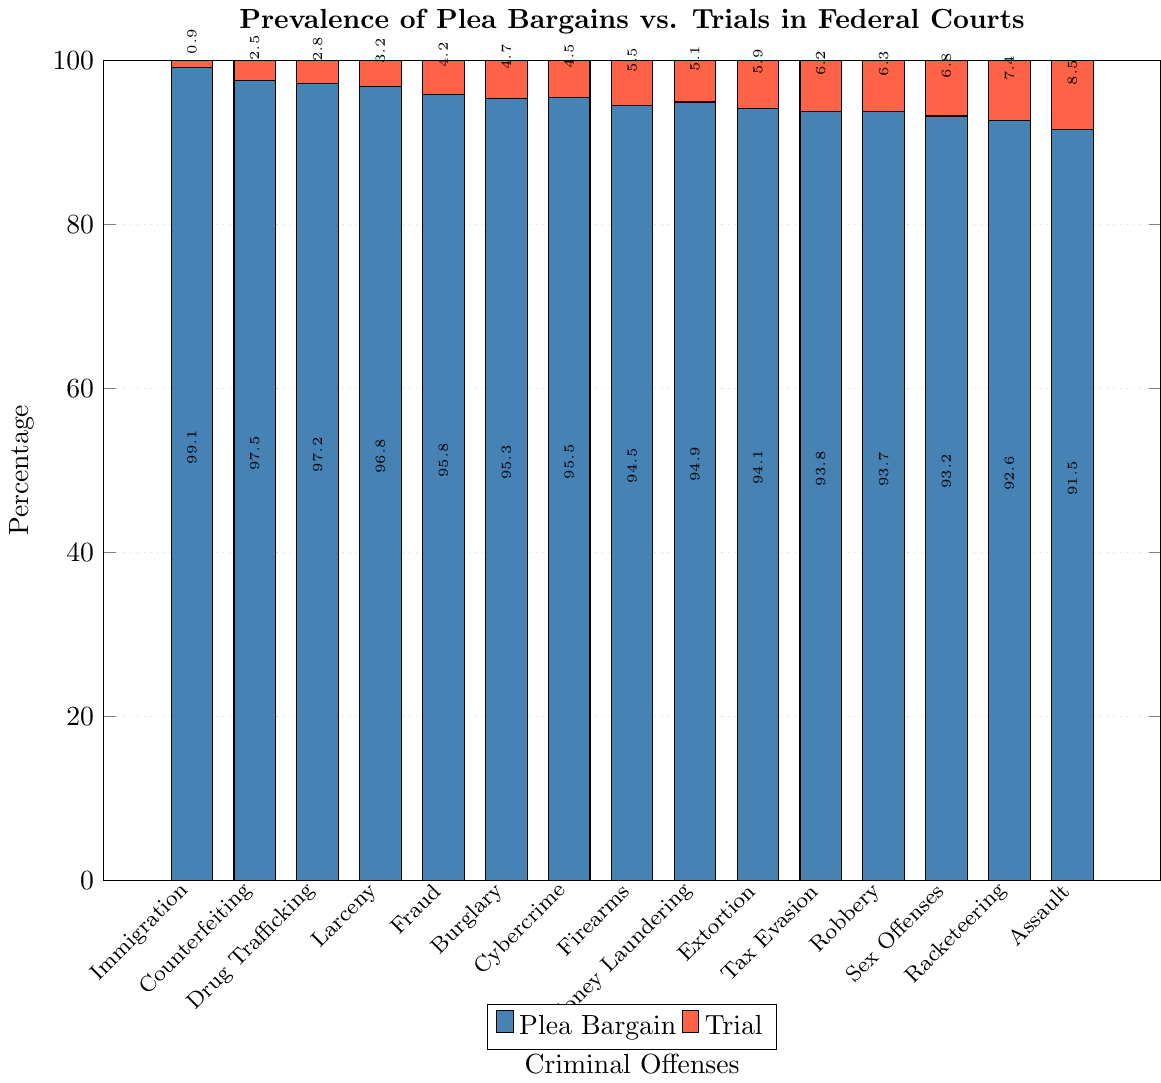What is the most common outcome for Drug Trafficking cases? Drug Trafficking cases have a plea bargain rate of 97.2% and a trial rate of 2.8%. The higher percentage indicates that plea bargains are the most common outcome for Drug Trafficking cases.
Answer: Plea Bargain Which offense has the highest percentage of plea bargains? The offense with the highest percentage of plea bargains is Immigration with 99.1%. This can be determined by looking at the bar heights for plea bargains across all offenses and identifying the tallest bar.
Answer: Immigration What is the difference in trial percentages between Assault and Fraud? The trial percentage for Assault is 8.5%, and for Fraud, it is 4.2%. The difference is calculated as 8.5% - 4.2% = 4.3%.
Answer: 4.3% Which two offenses have the smallest gap between plea bargains and trials? To find the smallest gap, we look at the differences between plea bargain and trial percentages for each offense. The offenses with the smallest gaps are likely to be close in their bar heights. Money Laundering has a plea bargain rate of 94.9% and a trial rate of 5.1%, giving a gap of 94.9% - 5.1% = 89.8%.
Answer: Money Laundering How many offenses have a trial percentage higher than 5%? By examining the graph, we count the bars representing trials that exceed 5% in height. The offenses with trial percentages higher than 5% are Assault (8.5%), Racketeering (7.4%), Sex Offenses (6.8%), Robbery (6.3%), Tax Evasion (6.2%), Firearms (5.5%), Money Laundering (5.1%), and Extortion (5.9%), yielding a total of 8 offenses.
Answer: 8 offenses What is the average trial percentage across all offenses? To calculate the average trial percentage, we sum the trial percentages for all offenses and divide by the number of offenses. The sum is 2.8% (Drug Trafficking) + 4.2% (Fraud) + 5.5% (Firearms) + 0.9% (Immigration) + 6.3% (Robbery) + 6.8% (Sex Offenses) + 8.5% (Assault) + 4.7% (Burglary) + 3.2% (Larceny) + 5.1% (Money Laundering) + 7.4% (Racketeering) + 4.5% (Cybercrime) + 6.2% (Tax Evasion) + 2.5% (Counterfeiting) + 5.9% (Extortion) = 74.5%. Then, 74.5% / 15 = 4.97%.
Answer: 4.97% Which offense has a trial rate closest to the average trial percentage? First, calculate the average trial percentage as 4.97%. Next, find the trial rate closest to this average. Fraud (4.2%) and Cybercrime (4.5%) are the closest to this value.
Answer: Cybercrime Compare the trial percentages of Cybercrime and Tax Evasion. Which is higher? The trial percentage for Cybercrime is 4.5%, and for Tax Evasion, it is 6.2%. Thus, the trial percentage of Tax Evasion is higher.
Answer: Tax Evasion What is the combined percentage for plea bargains and trials in Robbery cases? In Robbery cases, the plea bargain percentage is 93.7%, and the trial percentage is 6.3%. The combined percentage is 93.7% + 6.3% = 100%.
Answer: 100% 